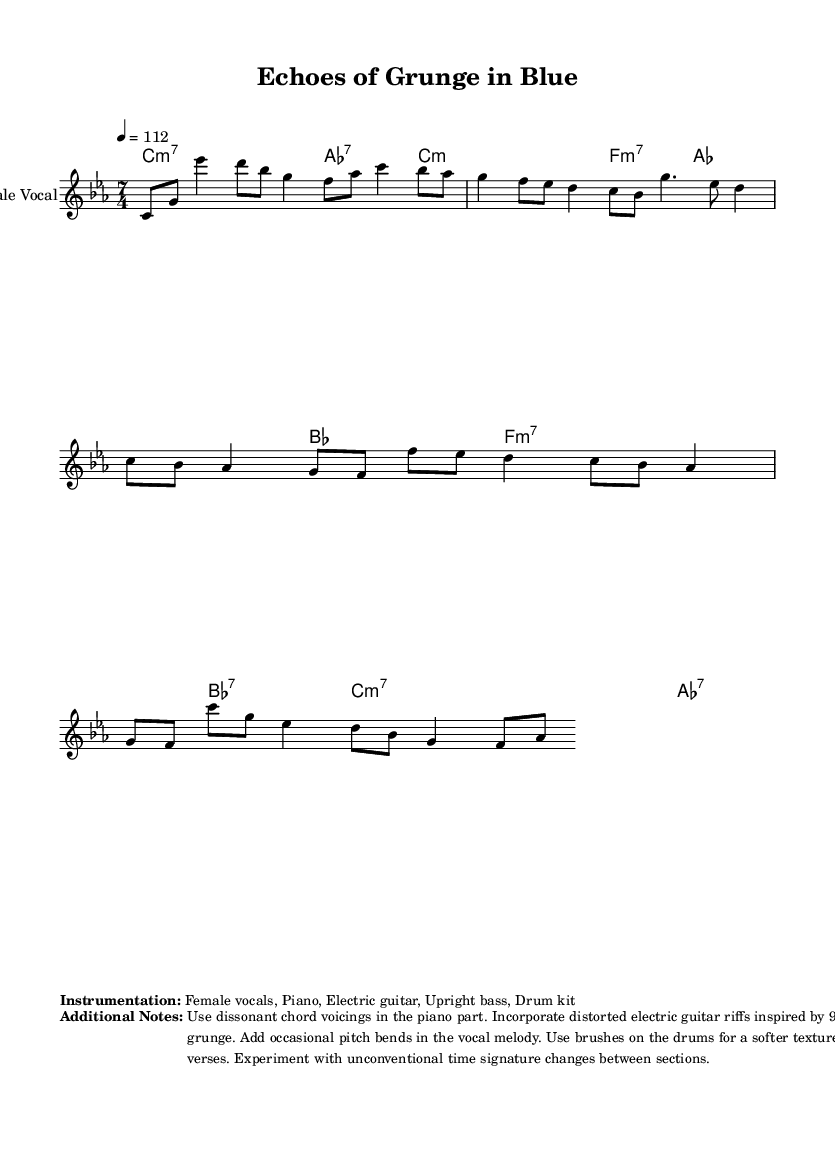What is the key signature of this music? The key signature is indicated at the beginning of the score, showing C minor. This means there are three flats: B flat, E flat, and A flat.
Answer: C minor What is the time signature of this piece? The time signature is present at the beginning of the score, represented as 7/4. This means there are seven beats per measure, and the quarter note gets one beat.
Answer: 7/4 What is the tempo marking of this composition? The tempo marking is specified in the score, showing a tempo of 4 equals 112, which indicates the beats per minute.
Answer: 112 What instruments are used in this piece? The instrumentation is detailed in the sheet music's markup section, listing female vocals, piano, electric guitar, upright bass, and drum kit.
Answer: Female vocals, Piano, Electric guitar, Upright bass, Drum kit What type of chords are primarily used in the harmonies? The chords in the harmony section mostly include minor 7th and dominant 7th chords, as indicated by the chord symbols next to each measure.
Answer: Minor 7th and Dominant 7th Why is the 7/4 time signature significant in this composition? The 7/4 time signature is uncommon and can create a unique rhythmic feel, allowing for complex phrasing that differs from traditional time signatures, making it particularly interesting in avant-garde jazz contexts. This encourages a sense of unpredictability in the music.
Answer: Unique rhythmic feel How does the vocal melody differ between the verses and the chorus? The vocal melody in the verses is more descending and features a mixture of half and quarter notes, while the chorus demonstrates a more ascending structure and includes longer note values like g4., creating a contrast in dynamics and energy between the two sections.
Answer: Descending in verses; ascending in chorus 